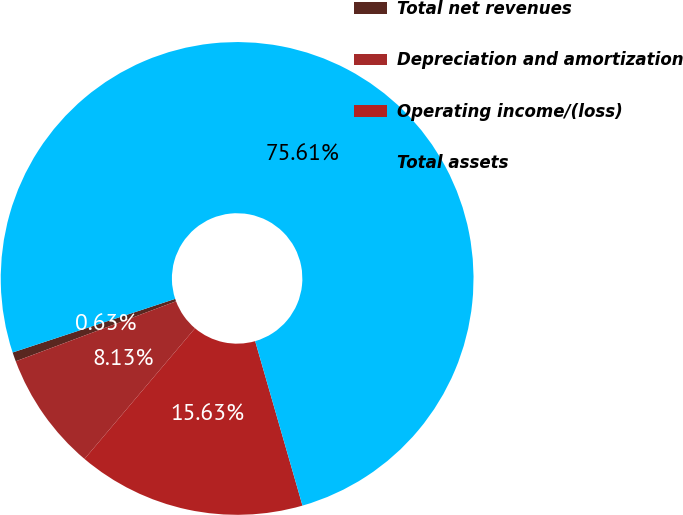Convert chart to OTSL. <chart><loc_0><loc_0><loc_500><loc_500><pie_chart><fcel>Total net revenues<fcel>Depreciation and amortization<fcel>Operating income/(loss)<fcel>Total assets<nl><fcel>0.63%<fcel>8.13%<fcel>15.63%<fcel>75.61%<nl></chart> 